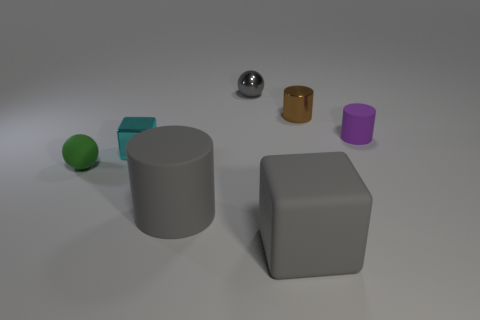Add 2 big matte cylinders. How many objects exist? 9 Subtract all spheres. How many objects are left? 5 Subtract 1 gray cylinders. How many objects are left? 6 Subtract all small gray balls. Subtract all small yellow things. How many objects are left? 6 Add 1 small gray balls. How many small gray balls are left? 2 Add 1 cyan metallic balls. How many cyan metallic balls exist? 1 